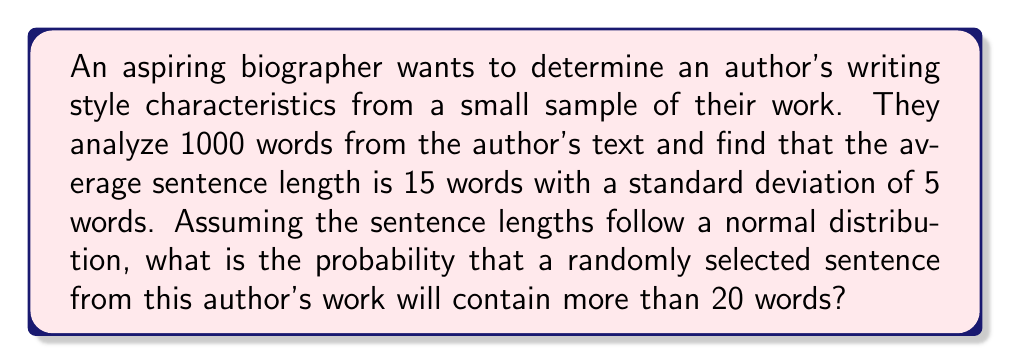Provide a solution to this math problem. To solve this problem, we need to use the properties of the normal distribution and the concept of z-scores. Let's follow these steps:

1. Identify the given information:
   - Mean sentence length (μ) = 15 words
   - Standard deviation (σ) = 5 words
   - We want to find P(X > 20), where X is the sentence length

2. Calculate the z-score for 20 words:
   $$ z = \frac{x - \mu}{\sigma} = \frac{20 - 15}{5} = 1 $$

3. Use the standard normal distribution table or a calculator to find the area to the right of z = 1:
   P(Z > 1) ≈ 0.1587

4. Therefore, the probability of a randomly selected sentence containing more than 20 words is approximately 0.1587 or 15.87%.

This analysis provides insight into the author's writing style, suggesting that about 15.87% of their sentences are longer than 20 words. This information can be valuable for a biographer to characterize the author's writing style in terms of sentence complexity and variation.
Answer: 0.1587 